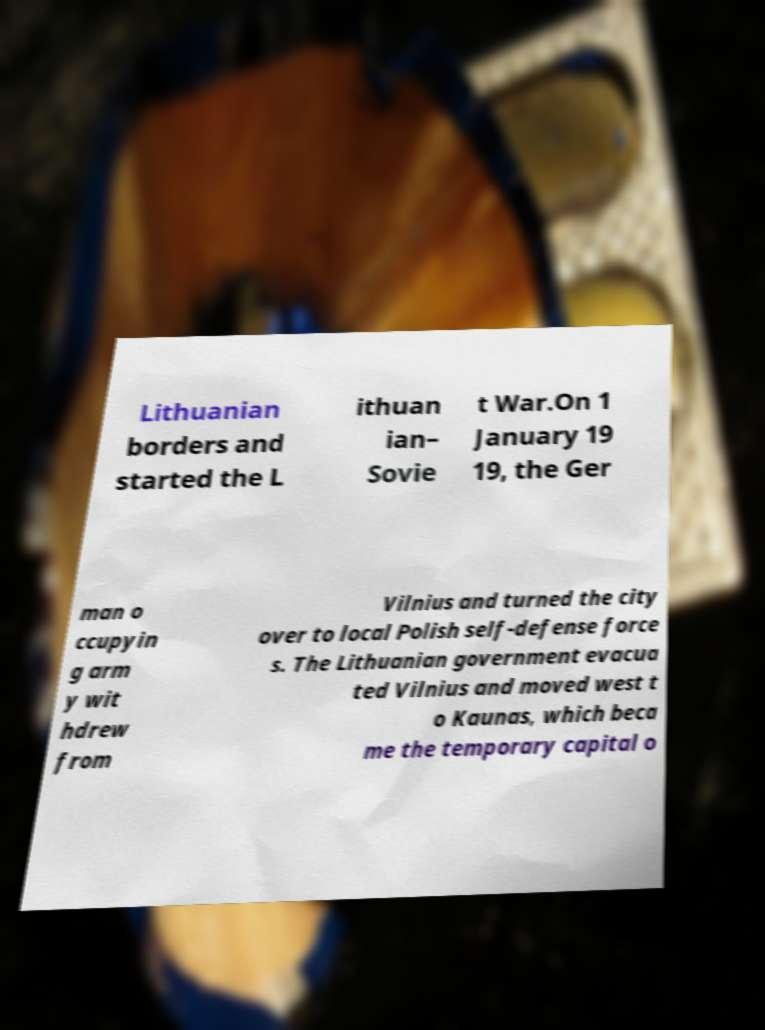For documentation purposes, I need the text within this image transcribed. Could you provide that? Lithuanian borders and started the L ithuan ian– Sovie t War.On 1 January 19 19, the Ger man o ccupyin g arm y wit hdrew from Vilnius and turned the city over to local Polish self-defense force s. The Lithuanian government evacua ted Vilnius and moved west t o Kaunas, which beca me the temporary capital o 